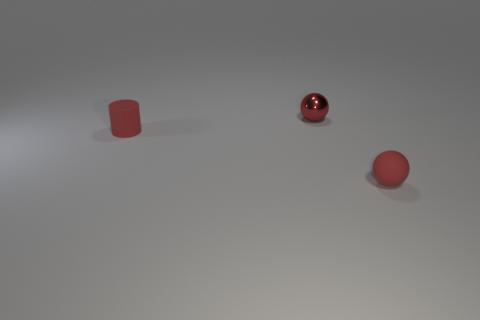Subtract all purple cylinders. Subtract all cyan balls. How many cylinders are left? 1 Add 3 matte balls. How many objects exist? 6 Subtract all balls. How many objects are left? 1 Add 3 tiny cylinders. How many tiny cylinders exist? 4 Subtract 0 purple blocks. How many objects are left? 3 Subtract all tiny rubber objects. Subtract all purple matte blocks. How many objects are left? 1 Add 1 red balls. How many red balls are left? 3 